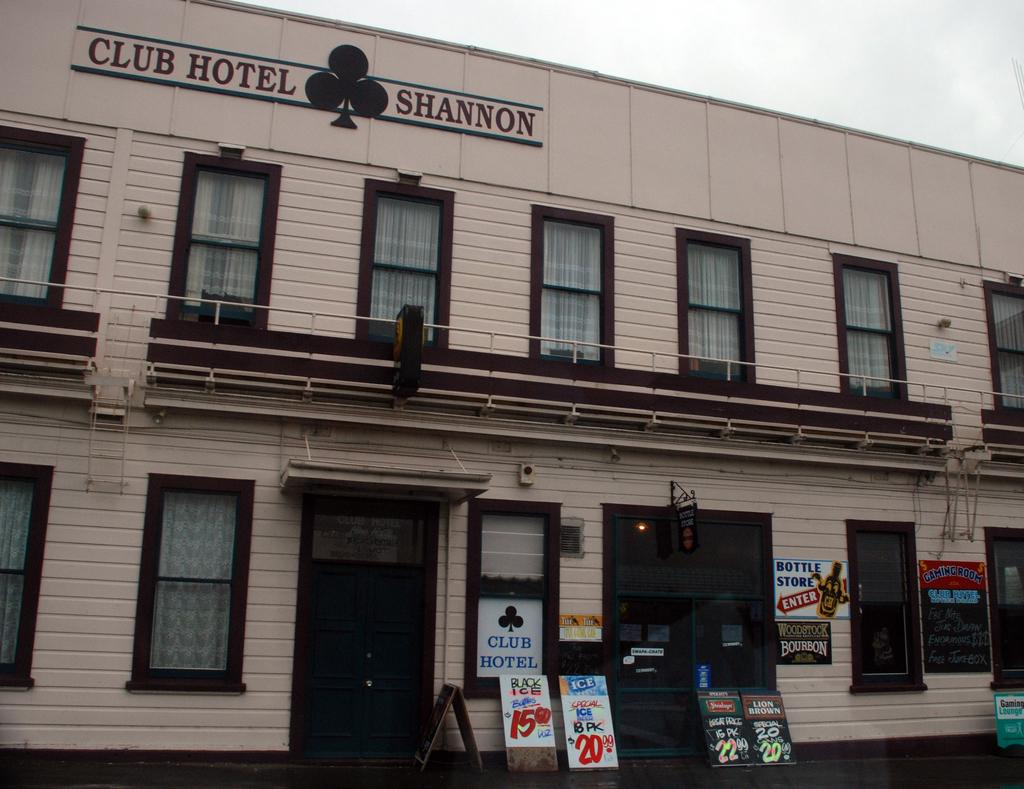What is the name of the hotel in the image? The hotel in the image is named "CLUB HOTEL SHANNON". What can be seen on the hotel's exterior? There are windows visible in the image. Are there any additional structures or objects near the hotel? Yes, there are boards near the hotel. What is visible at the top of the image? The sky is visible at the top of the image. Can you tell me how many fields are visible in the image? There are no fields visible in the image; it features a hotel named "CLUB HOTEL SHANNON" with windows, boards, and a visible sky. What type of club is associated with the hotel in the image? There is no specific club mentioned or depicted in the image; it only features the hotel named "CLUB HOTEL SHANNON". 